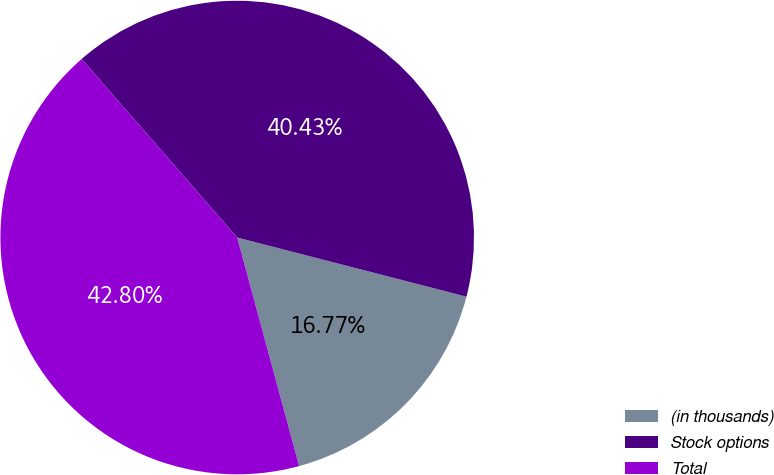Convert chart to OTSL. <chart><loc_0><loc_0><loc_500><loc_500><pie_chart><fcel>(in thousands)<fcel>Stock options<fcel>Total<nl><fcel>16.77%<fcel>40.43%<fcel>42.8%<nl></chart> 